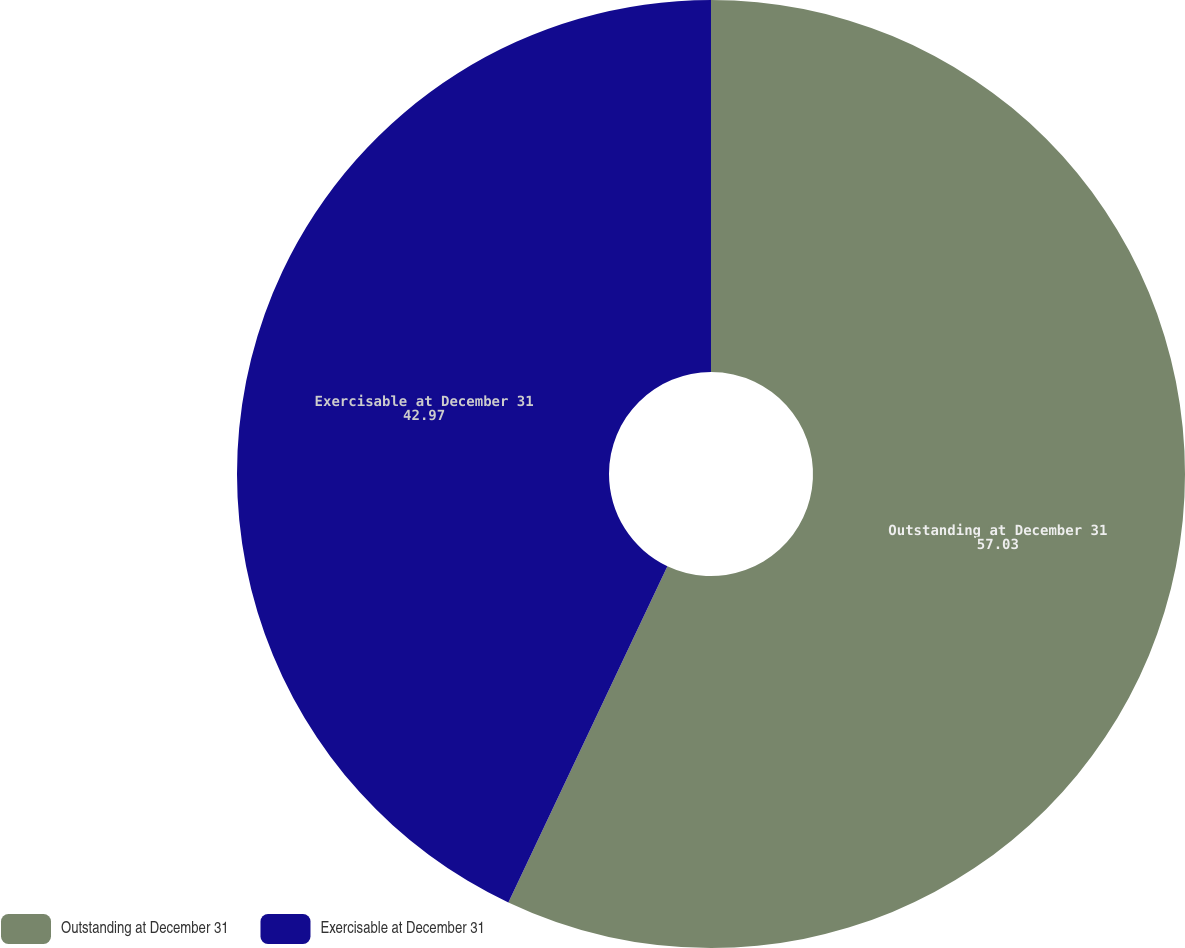<chart> <loc_0><loc_0><loc_500><loc_500><pie_chart><fcel>Outstanding at December 31<fcel>Exercisable at December 31<nl><fcel>57.03%<fcel>42.97%<nl></chart> 